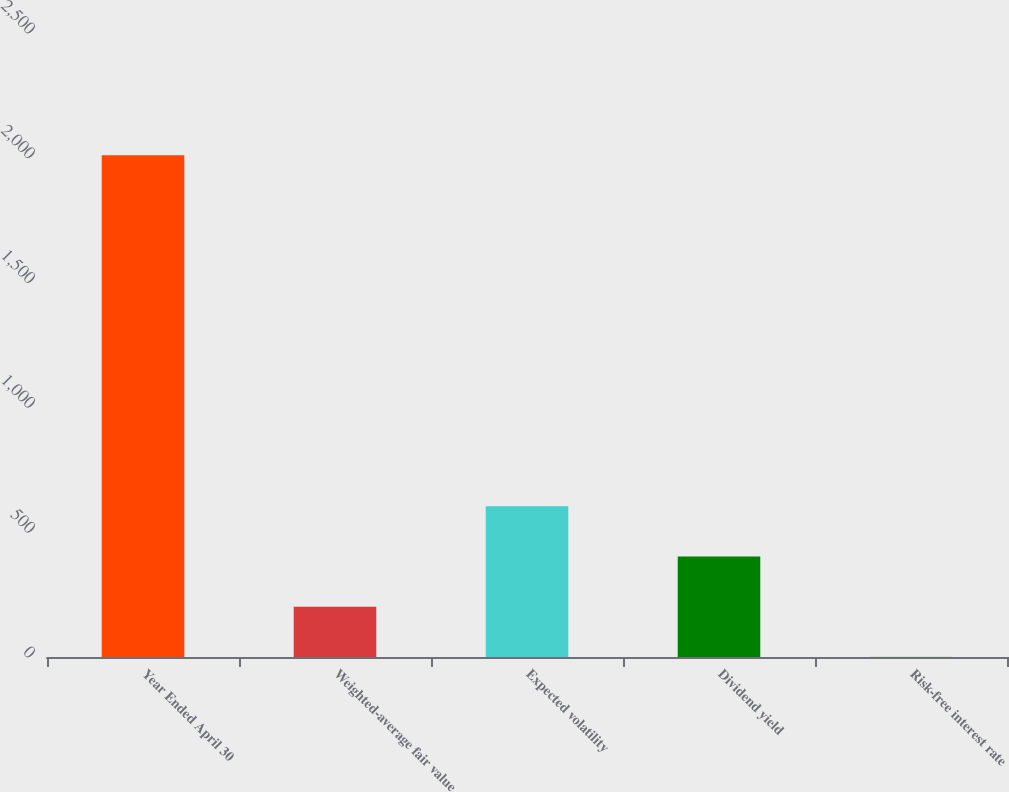<chart> <loc_0><loc_0><loc_500><loc_500><bar_chart><fcel>Year Ended April 30<fcel>Weighted-average fair value<fcel>Expected volatility<fcel>Dividend yield<fcel>Risk-free interest rate<nl><fcel>2010<fcel>201.77<fcel>603.61<fcel>402.69<fcel>0.85<nl></chart> 